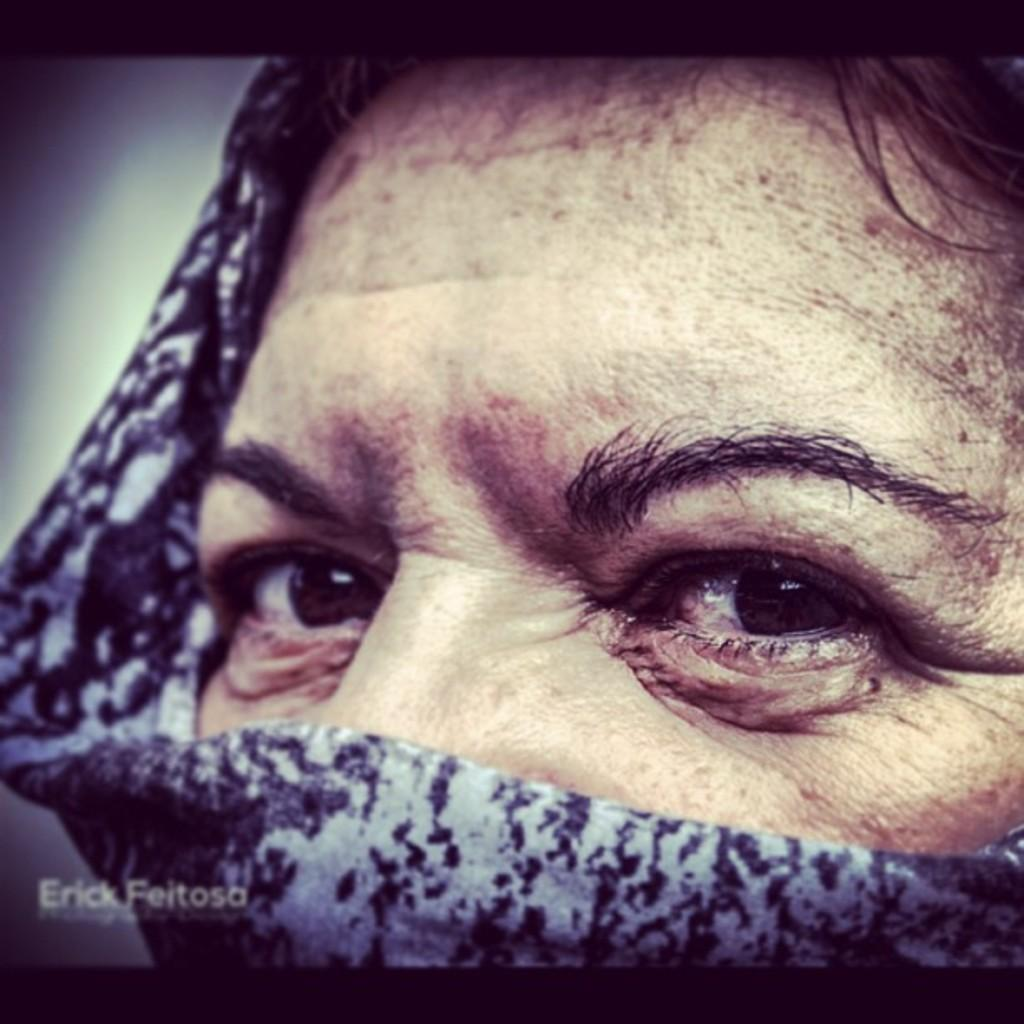What is the main subject of the image? The main subject of the image is a photograph of a person's face. How much of the photograph is covered in the image? The photograph is half covered with a cloth. What features of the person's face can be seen in the image? The person's eyes are visible in the image, and some part of the person's hair is visible. What type of appliance is being used by the person in the image? There is no appliance visible in the image; it only shows a photograph of a person's face. What type of flight is the person taking in the image? There is no indication of a flight or any travel-related activity in the image. 